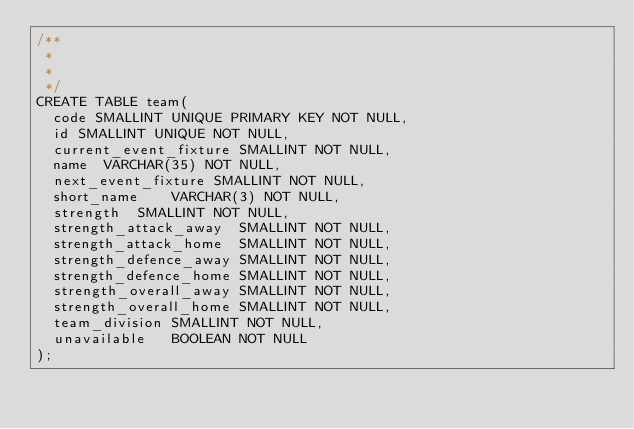<code> <loc_0><loc_0><loc_500><loc_500><_SQL_>/**
 *
 *
 */
CREATE TABLE team(
  code SMALLINT UNIQUE PRIMARY KEY NOT NULL,
  id SMALLINT UNIQUE NOT NULL,
  current_event_fixture	SMALLINT NOT NULL,
  name	VARCHAR(35) NOT NULL,
  next_event_fixture SMALLINT NOT NULL,
  short_name	VARCHAR(3) NOT NULL,
  strength	SMALLINT NOT NULL,
  strength_attack_away	SMALLINT NOT NULL,
  strength_attack_home	SMALLINT NOT NULL,
  strength_defence_away	SMALLINT NOT NULL,
  strength_defence_home	SMALLINT NOT NULL,
  strength_overall_away	SMALLINT NOT NULL,
  strength_overall_home	SMALLINT NOT NULL,
  team_division	SMALLINT NOT NULL,
  unavailable	BOOLEAN NOT NULL
);</code> 